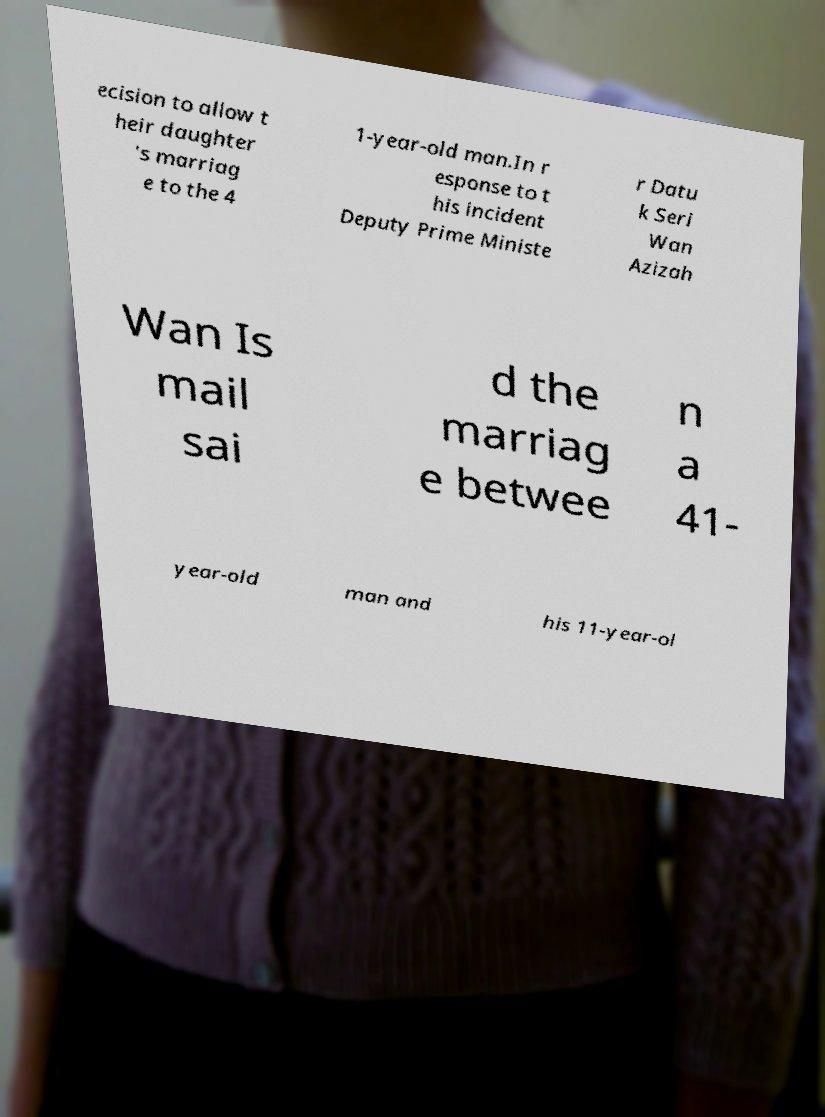For documentation purposes, I need the text within this image transcribed. Could you provide that? ecision to allow t heir daughter 's marriag e to the 4 1-year-old man.In r esponse to t his incident Deputy Prime Ministe r Datu k Seri Wan Azizah Wan Is mail sai d the marriag e betwee n a 41- year-old man and his 11-year-ol 